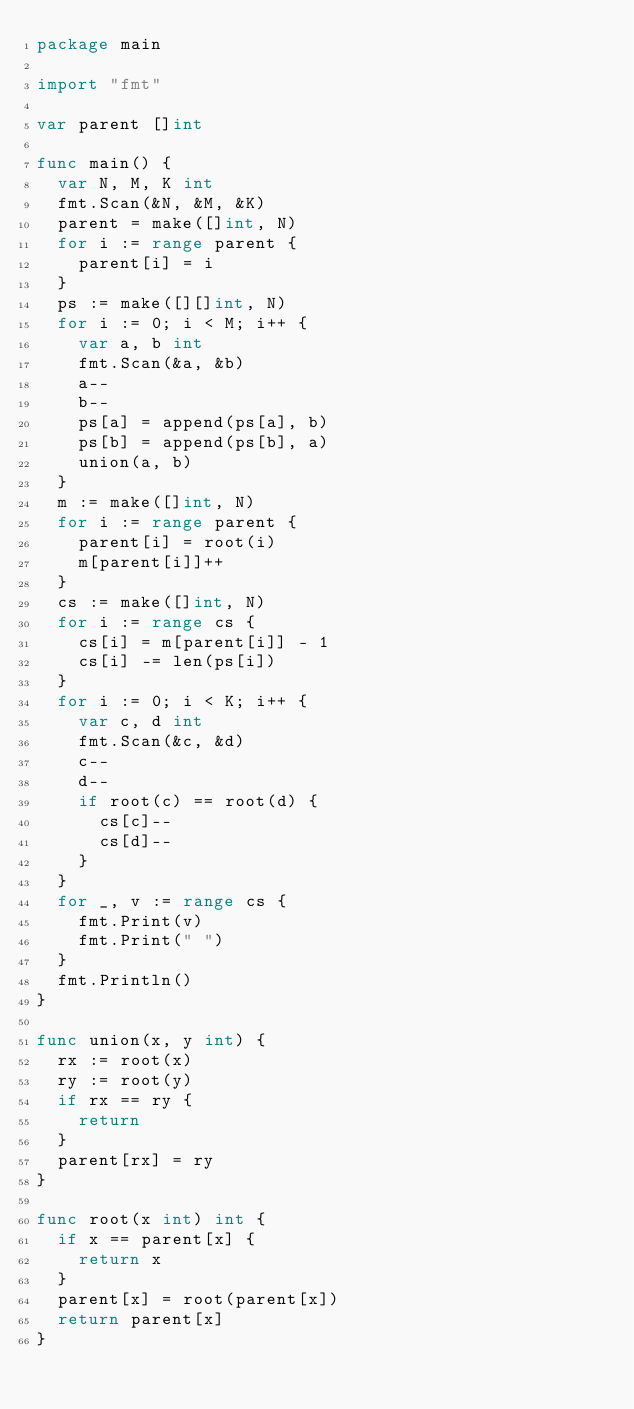<code> <loc_0><loc_0><loc_500><loc_500><_Go_>package main

import "fmt"

var parent []int

func main() {
	var N, M, K int
	fmt.Scan(&N, &M, &K)
	parent = make([]int, N)
	for i := range parent {
		parent[i] = i
	}
	ps := make([][]int, N)
	for i := 0; i < M; i++ {
		var a, b int
		fmt.Scan(&a, &b)
		a--
		b--
		ps[a] = append(ps[a], b)
		ps[b] = append(ps[b], a)
		union(a, b)
	}
	m := make([]int, N)
	for i := range parent {
		parent[i] = root(i)
		m[parent[i]]++
	}
	cs := make([]int, N)
	for i := range cs {
		cs[i] = m[parent[i]] - 1
		cs[i] -= len(ps[i])
	}
	for i := 0; i < K; i++ {
		var c, d int
		fmt.Scan(&c, &d)
		c--
		d--
		if root(c) == root(d) {
			cs[c]--
			cs[d]--
		}
	}
	for _, v := range cs {
		fmt.Print(v)
		fmt.Print(" ")
	}
	fmt.Println()
}

func union(x, y int) {
	rx := root(x)
	ry := root(y)
	if rx == ry {
		return
	}
	parent[rx] = ry
}

func root(x int) int {
	if x == parent[x] {
		return x
	}
	parent[x] = root(parent[x])
	return parent[x]
}
</code> 